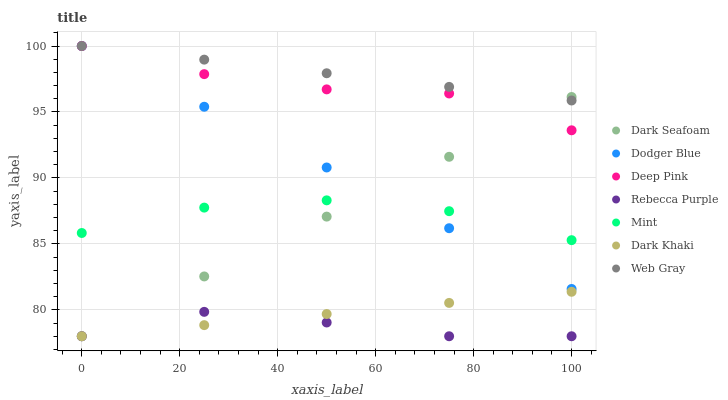Does Rebecca Purple have the minimum area under the curve?
Answer yes or no. Yes. Does Web Gray have the maximum area under the curve?
Answer yes or no. Yes. Does Dark Khaki have the minimum area under the curve?
Answer yes or no. No. Does Dark Khaki have the maximum area under the curve?
Answer yes or no. No. Is Dark Khaki the smoothest?
Answer yes or no. Yes. Is Deep Pink the roughest?
Answer yes or no. Yes. Is Dark Seafoam the smoothest?
Answer yes or no. No. Is Dark Seafoam the roughest?
Answer yes or no. No. Does Dark Khaki have the lowest value?
Answer yes or no. Yes. Does Web Gray have the lowest value?
Answer yes or no. No. Does Dodger Blue have the highest value?
Answer yes or no. Yes. Does Dark Khaki have the highest value?
Answer yes or no. No. Is Dark Khaki less than Deep Pink?
Answer yes or no. Yes. Is Web Gray greater than Rebecca Purple?
Answer yes or no. Yes. Does Dodger Blue intersect Deep Pink?
Answer yes or no. Yes. Is Dodger Blue less than Deep Pink?
Answer yes or no. No. Is Dodger Blue greater than Deep Pink?
Answer yes or no. No. Does Dark Khaki intersect Deep Pink?
Answer yes or no. No. 